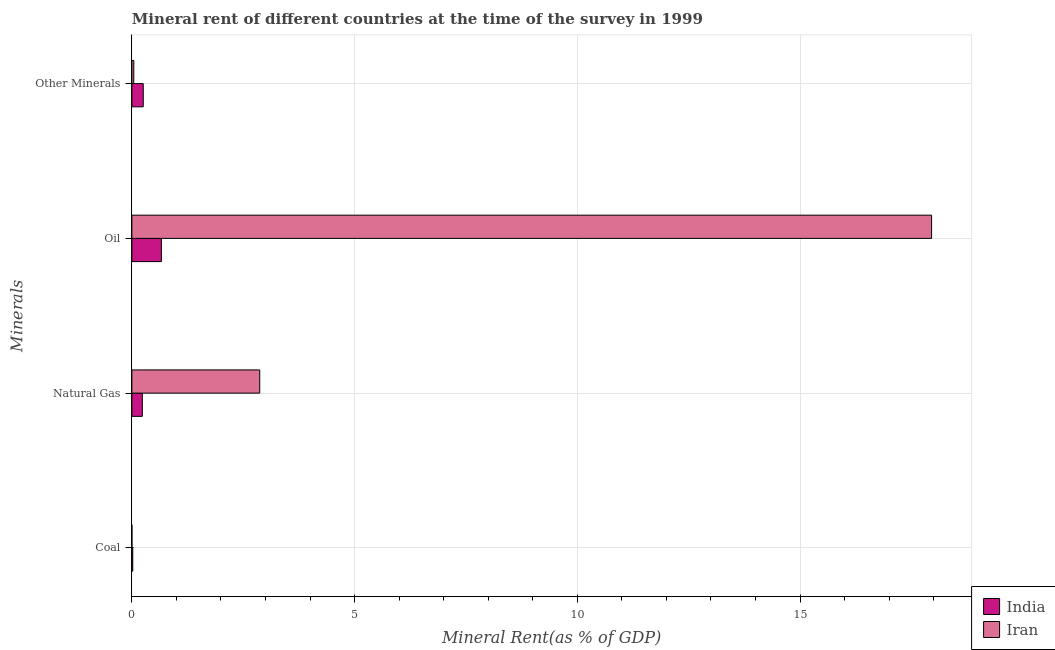How many groups of bars are there?
Your answer should be compact. 4. Are the number of bars on each tick of the Y-axis equal?
Make the answer very short. Yes. How many bars are there on the 3rd tick from the bottom?
Your answer should be compact. 2. What is the label of the 3rd group of bars from the top?
Your answer should be compact. Natural Gas. What is the  rent of other minerals in India?
Your answer should be very brief. 0.26. Across all countries, what is the maximum  rent of other minerals?
Give a very brief answer. 0.26. Across all countries, what is the minimum  rent of other minerals?
Provide a short and direct response. 0.04. In which country was the oil rent maximum?
Your response must be concise. Iran. In which country was the  rent of other minerals minimum?
Give a very brief answer. Iran. What is the total oil rent in the graph?
Offer a very short reply. 18.62. What is the difference between the oil rent in Iran and that in India?
Provide a succinct answer. 17.29. What is the difference between the  rent of other minerals in India and the natural gas rent in Iran?
Give a very brief answer. -2.62. What is the average oil rent per country?
Give a very brief answer. 9.31. What is the difference between the  rent of other minerals and natural gas rent in India?
Offer a very short reply. 0.02. What is the ratio of the  rent of other minerals in Iran to that in India?
Keep it short and to the point. 0.17. Is the difference between the coal rent in Iran and India greater than the difference between the oil rent in Iran and India?
Provide a short and direct response. No. What is the difference between the highest and the second highest natural gas rent?
Make the answer very short. 2.64. What is the difference between the highest and the lowest  rent of other minerals?
Make the answer very short. 0.21. In how many countries, is the  rent of other minerals greater than the average  rent of other minerals taken over all countries?
Ensure brevity in your answer.  1. How many bars are there?
Provide a succinct answer. 8. How many countries are there in the graph?
Keep it short and to the point. 2. What is the difference between two consecutive major ticks on the X-axis?
Keep it short and to the point. 5. Are the values on the major ticks of X-axis written in scientific E-notation?
Make the answer very short. No. Does the graph contain any zero values?
Ensure brevity in your answer.  No. How are the legend labels stacked?
Provide a short and direct response. Vertical. What is the title of the graph?
Provide a succinct answer. Mineral rent of different countries at the time of the survey in 1999. What is the label or title of the X-axis?
Offer a terse response. Mineral Rent(as % of GDP). What is the label or title of the Y-axis?
Make the answer very short. Minerals. What is the Mineral Rent(as % of GDP) in India in Coal?
Provide a succinct answer. 0.02. What is the Mineral Rent(as % of GDP) of Iran in Coal?
Provide a short and direct response. 0. What is the Mineral Rent(as % of GDP) of India in Natural Gas?
Offer a very short reply. 0.23. What is the Mineral Rent(as % of GDP) of Iran in Natural Gas?
Give a very brief answer. 2.87. What is the Mineral Rent(as % of GDP) in India in Oil?
Your response must be concise. 0.66. What is the Mineral Rent(as % of GDP) in Iran in Oil?
Ensure brevity in your answer.  17.95. What is the Mineral Rent(as % of GDP) of India in Other Minerals?
Your answer should be compact. 0.26. What is the Mineral Rent(as % of GDP) in Iran in Other Minerals?
Provide a short and direct response. 0.04. Across all Minerals, what is the maximum Mineral Rent(as % of GDP) of India?
Offer a terse response. 0.66. Across all Minerals, what is the maximum Mineral Rent(as % of GDP) of Iran?
Offer a terse response. 17.95. Across all Minerals, what is the minimum Mineral Rent(as % of GDP) of India?
Provide a succinct answer. 0.02. Across all Minerals, what is the minimum Mineral Rent(as % of GDP) in Iran?
Provide a succinct answer. 0. What is the total Mineral Rent(as % of GDP) in India in the graph?
Give a very brief answer. 1.17. What is the total Mineral Rent(as % of GDP) in Iran in the graph?
Keep it short and to the point. 20.87. What is the difference between the Mineral Rent(as % of GDP) in India in Coal and that in Natural Gas?
Provide a short and direct response. -0.21. What is the difference between the Mineral Rent(as % of GDP) in Iran in Coal and that in Natural Gas?
Your response must be concise. -2.87. What is the difference between the Mineral Rent(as % of GDP) in India in Coal and that in Oil?
Provide a short and direct response. -0.64. What is the difference between the Mineral Rent(as % of GDP) in Iran in Coal and that in Oil?
Provide a succinct answer. -17.95. What is the difference between the Mineral Rent(as % of GDP) of India in Coal and that in Other Minerals?
Ensure brevity in your answer.  -0.24. What is the difference between the Mineral Rent(as % of GDP) of Iran in Coal and that in Other Minerals?
Your answer should be compact. -0.04. What is the difference between the Mineral Rent(as % of GDP) of India in Natural Gas and that in Oil?
Offer a very short reply. -0.43. What is the difference between the Mineral Rent(as % of GDP) of Iran in Natural Gas and that in Oil?
Offer a very short reply. -15.08. What is the difference between the Mineral Rent(as % of GDP) in India in Natural Gas and that in Other Minerals?
Ensure brevity in your answer.  -0.02. What is the difference between the Mineral Rent(as % of GDP) of Iran in Natural Gas and that in Other Minerals?
Provide a short and direct response. 2.83. What is the difference between the Mineral Rent(as % of GDP) of India in Oil and that in Other Minerals?
Make the answer very short. 0.41. What is the difference between the Mineral Rent(as % of GDP) in Iran in Oil and that in Other Minerals?
Provide a succinct answer. 17.91. What is the difference between the Mineral Rent(as % of GDP) in India in Coal and the Mineral Rent(as % of GDP) in Iran in Natural Gas?
Keep it short and to the point. -2.85. What is the difference between the Mineral Rent(as % of GDP) of India in Coal and the Mineral Rent(as % of GDP) of Iran in Oil?
Offer a terse response. -17.93. What is the difference between the Mineral Rent(as % of GDP) in India in Coal and the Mineral Rent(as % of GDP) in Iran in Other Minerals?
Provide a short and direct response. -0.02. What is the difference between the Mineral Rent(as % of GDP) of India in Natural Gas and the Mineral Rent(as % of GDP) of Iran in Oil?
Your answer should be compact. -17.72. What is the difference between the Mineral Rent(as % of GDP) of India in Natural Gas and the Mineral Rent(as % of GDP) of Iran in Other Minerals?
Give a very brief answer. 0.19. What is the difference between the Mineral Rent(as % of GDP) in India in Oil and the Mineral Rent(as % of GDP) in Iran in Other Minerals?
Ensure brevity in your answer.  0.62. What is the average Mineral Rent(as % of GDP) of India per Minerals?
Provide a succinct answer. 0.29. What is the average Mineral Rent(as % of GDP) in Iran per Minerals?
Ensure brevity in your answer.  5.22. What is the difference between the Mineral Rent(as % of GDP) in India and Mineral Rent(as % of GDP) in Iran in Coal?
Offer a very short reply. 0.02. What is the difference between the Mineral Rent(as % of GDP) in India and Mineral Rent(as % of GDP) in Iran in Natural Gas?
Your answer should be compact. -2.64. What is the difference between the Mineral Rent(as % of GDP) of India and Mineral Rent(as % of GDP) of Iran in Oil?
Offer a very short reply. -17.29. What is the difference between the Mineral Rent(as % of GDP) in India and Mineral Rent(as % of GDP) in Iran in Other Minerals?
Make the answer very short. 0.21. What is the ratio of the Mineral Rent(as % of GDP) of India in Coal to that in Natural Gas?
Offer a terse response. 0.09. What is the ratio of the Mineral Rent(as % of GDP) in India in Coal to that in Oil?
Your response must be concise. 0.03. What is the ratio of the Mineral Rent(as % of GDP) in Iran in Coal to that in Oil?
Give a very brief answer. 0. What is the ratio of the Mineral Rent(as % of GDP) of India in Coal to that in Other Minerals?
Provide a short and direct response. 0.08. What is the ratio of the Mineral Rent(as % of GDP) in Iran in Coal to that in Other Minerals?
Give a very brief answer. 0.01. What is the ratio of the Mineral Rent(as % of GDP) of India in Natural Gas to that in Oil?
Make the answer very short. 0.35. What is the ratio of the Mineral Rent(as % of GDP) in Iran in Natural Gas to that in Oil?
Provide a succinct answer. 0.16. What is the ratio of the Mineral Rent(as % of GDP) of India in Natural Gas to that in Other Minerals?
Keep it short and to the point. 0.92. What is the ratio of the Mineral Rent(as % of GDP) in Iran in Natural Gas to that in Other Minerals?
Ensure brevity in your answer.  66.56. What is the ratio of the Mineral Rent(as % of GDP) in India in Oil to that in Other Minerals?
Provide a short and direct response. 2.6. What is the ratio of the Mineral Rent(as % of GDP) of Iran in Oil to that in Other Minerals?
Your answer should be very brief. 416.33. What is the difference between the highest and the second highest Mineral Rent(as % of GDP) in India?
Give a very brief answer. 0.41. What is the difference between the highest and the second highest Mineral Rent(as % of GDP) of Iran?
Offer a very short reply. 15.08. What is the difference between the highest and the lowest Mineral Rent(as % of GDP) of India?
Keep it short and to the point. 0.64. What is the difference between the highest and the lowest Mineral Rent(as % of GDP) of Iran?
Your answer should be compact. 17.95. 